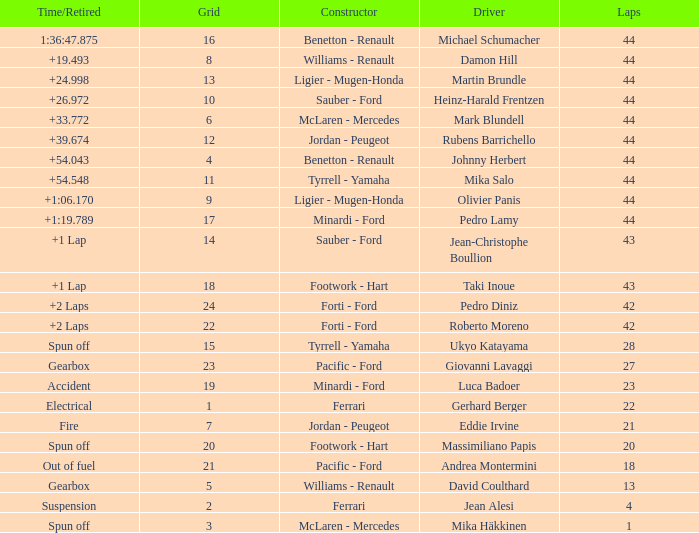Who built the car that ran out of fuel before 28 laps? Pacific - Ford. 